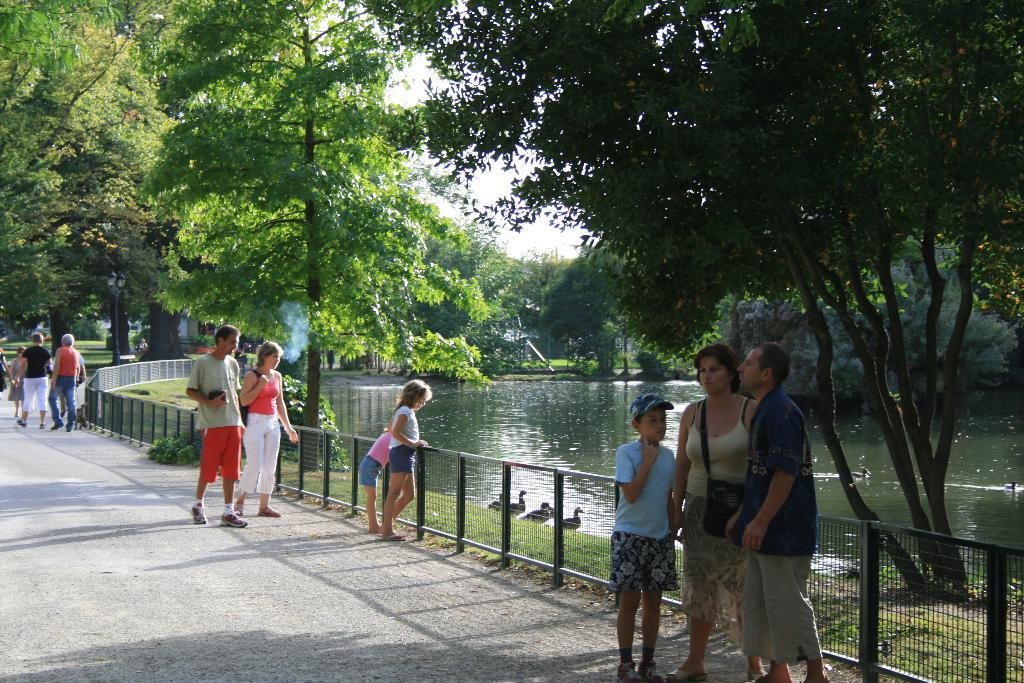What is the main feature of the image? There is a road in the image. What are the people on the road doing? There are people standing on the road. What type of barrier is present in the image? There is fencing in the image. What type of vegetation can be seen in the image? Grass is present in the image. What can be observed about the lighting in the image? Shadows are visible in the image. What natural element is present in the image? There is water in the image. What type of plants are in the image? There are trees in the image. What type of animals are in the image? There are birds in the image. What type of regret is expressed by the birds in the image? There is no indication of regret in the image, as it features birds and other elements but does not convey emotions or expressions. 